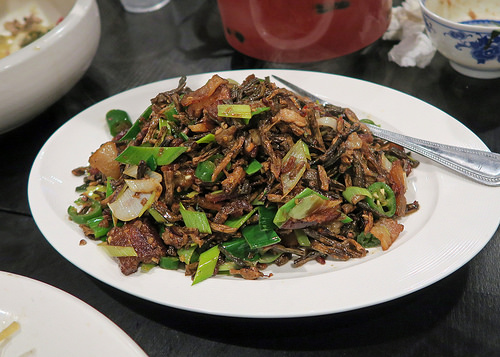<image>
Is the fork behind the food? Yes. From this viewpoint, the fork is positioned behind the food, with the food partially or fully occluding the fork. Is the food in the plate? Yes. The food is contained within or inside the plate, showing a containment relationship. 